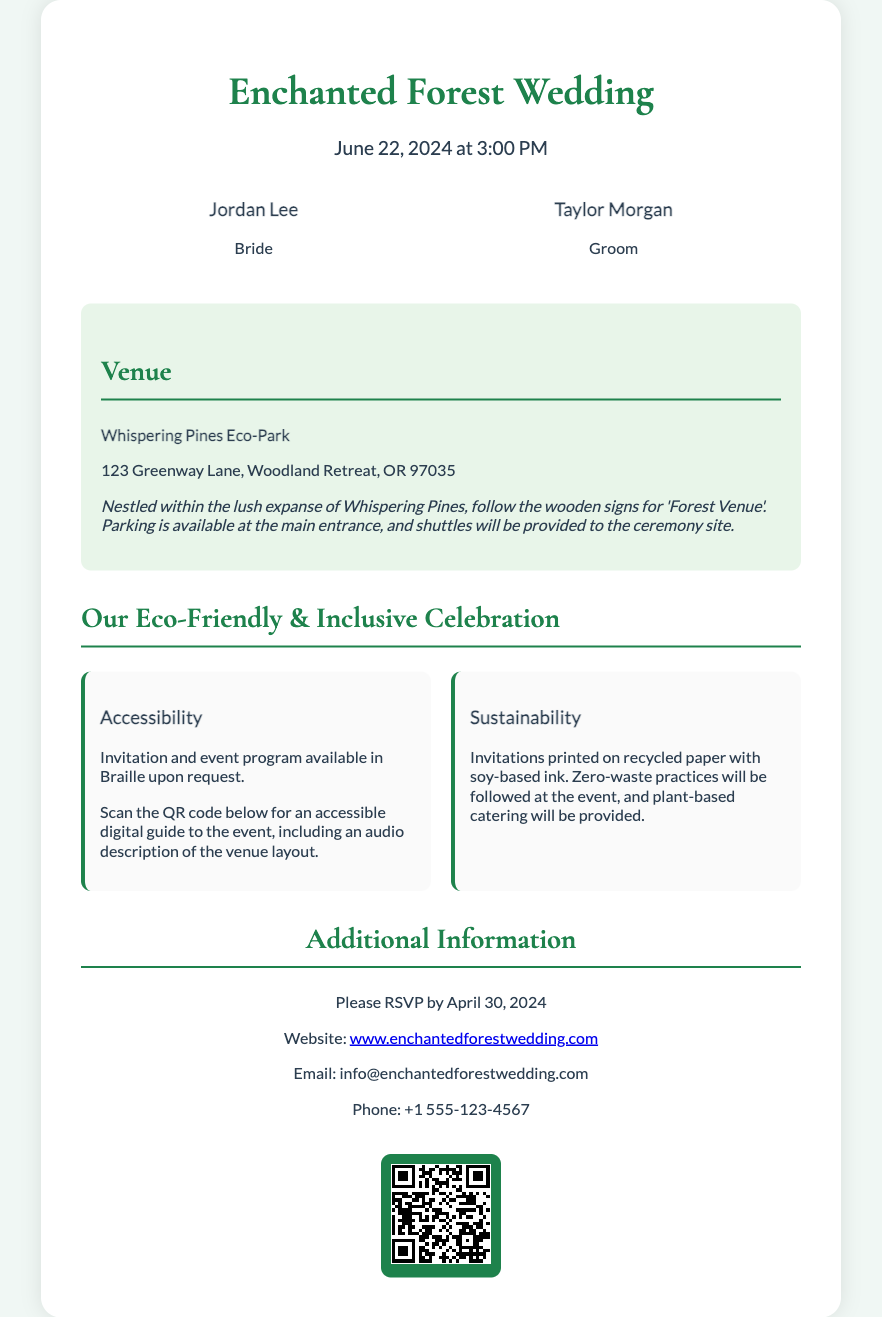What is the name of the venue? The venue name is specified in the document, which is the location of the wedding celebration.
Answer: Whispering Pines Eco-Park What is the wedding date? The wedding date is listed in the document, indicating when the event will take place.
Answer: June 22, 2024 Who are the hosts of the wedding? The document provides the names of the individuals hosting the wedding celebration.
Answer: Jordan Lee and Taylor Morgan What is the RSVP deadline? The RSVP deadline is mentioned in the document for guests to confirm their attendance.
Answer: April 30, 2024 What type of catering will be provided? The document details the type of food service that will be offered at the event.
Answer: Plant-based catering Why is the invitation eco-friendly? The document explains the measures taken to ensure the invitation is environmentally friendly.
Answer: Printed on recycled paper with soy-based ink What is available upon request? The document specifies an item that can be provided to enhance accessibility for guests.
Answer: Braille invitation and event program What additional feature does the QR code provide? The document outlines the benefit of scanning the QR code included in the invitation.
Answer: An accessible digital guide to the event How will shuttles be organized? The document describes the method of transportation available for guests attending the wedding.
Answer: Provided to the ceremony site 